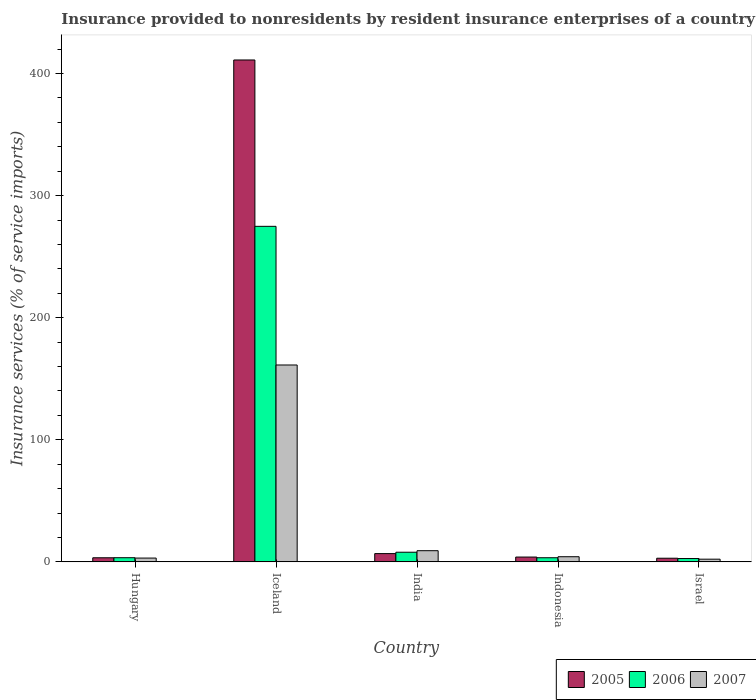How many different coloured bars are there?
Make the answer very short. 3. Are the number of bars per tick equal to the number of legend labels?
Your answer should be very brief. Yes. How many bars are there on the 2nd tick from the left?
Keep it short and to the point. 3. How many bars are there on the 4th tick from the right?
Make the answer very short. 3. What is the label of the 5th group of bars from the left?
Keep it short and to the point. Israel. In how many cases, is the number of bars for a given country not equal to the number of legend labels?
Your answer should be very brief. 0. What is the insurance provided to nonresidents in 2006 in Israel?
Offer a terse response. 2.73. Across all countries, what is the maximum insurance provided to nonresidents in 2007?
Ensure brevity in your answer.  161.27. Across all countries, what is the minimum insurance provided to nonresidents in 2005?
Your answer should be compact. 2.98. What is the total insurance provided to nonresidents in 2005 in the graph?
Provide a short and direct response. 428.22. What is the difference between the insurance provided to nonresidents in 2006 in Iceland and that in Indonesia?
Your response must be concise. 271.48. What is the difference between the insurance provided to nonresidents in 2006 in Hungary and the insurance provided to nonresidents in 2007 in India?
Keep it short and to the point. -5.75. What is the average insurance provided to nonresidents in 2005 per country?
Offer a terse response. 85.64. What is the difference between the insurance provided to nonresidents of/in 2007 and insurance provided to nonresidents of/in 2005 in Hungary?
Give a very brief answer. -0.25. In how many countries, is the insurance provided to nonresidents in 2006 greater than 140 %?
Give a very brief answer. 1. What is the ratio of the insurance provided to nonresidents in 2006 in Hungary to that in Iceland?
Your answer should be very brief. 0.01. Is the insurance provided to nonresidents in 2005 in Hungary less than that in Israel?
Make the answer very short. No. What is the difference between the highest and the second highest insurance provided to nonresidents in 2007?
Make the answer very short. 157.05. What is the difference between the highest and the lowest insurance provided to nonresidents in 2006?
Provide a succinct answer. 272.13. In how many countries, is the insurance provided to nonresidents in 2007 greater than the average insurance provided to nonresidents in 2007 taken over all countries?
Ensure brevity in your answer.  1. What does the 2nd bar from the right in Iceland represents?
Keep it short and to the point. 2006. Is it the case that in every country, the sum of the insurance provided to nonresidents in 2007 and insurance provided to nonresidents in 2005 is greater than the insurance provided to nonresidents in 2006?
Offer a very short reply. Yes. Are all the bars in the graph horizontal?
Ensure brevity in your answer.  No. Does the graph contain grids?
Give a very brief answer. No. Where does the legend appear in the graph?
Provide a succinct answer. Bottom right. What is the title of the graph?
Make the answer very short. Insurance provided to nonresidents by resident insurance enterprises of a country. What is the label or title of the Y-axis?
Keep it short and to the point. Insurance services (% of service imports). What is the Insurance services (% of service imports) in 2005 in Hungary?
Offer a very short reply. 3.36. What is the Insurance services (% of service imports) in 2006 in Hungary?
Your response must be concise. 3.4. What is the Insurance services (% of service imports) of 2007 in Hungary?
Keep it short and to the point. 3.11. What is the Insurance services (% of service imports) in 2005 in Iceland?
Ensure brevity in your answer.  411.14. What is the Insurance services (% of service imports) in 2006 in Iceland?
Provide a succinct answer. 274.86. What is the Insurance services (% of service imports) of 2007 in Iceland?
Provide a succinct answer. 161.27. What is the Insurance services (% of service imports) in 2005 in India?
Your answer should be compact. 6.78. What is the Insurance services (% of service imports) in 2006 in India?
Make the answer very short. 7.9. What is the Insurance services (% of service imports) in 2007 in India?
Your response must be concise. 9.16. What is the Insurance services (% of service imports) of 2005 in Indonesia?
Provide a short and direct response. 3.95. What is the Insurance services (% of service imports) of 2006 in Indonesia?
Provide a succinct answer. 3.38. What is the Insurance services (% of service imports) in 2007 in Indonesia?
Make the answer very short. 4.22. What is the Insurance services (% of service imports) of 2005 in Israel?
Make the answer very short. 2.98. What is the Insurance services (% of service imports) in 2006 in Israel?
Provide a succinct answer. 2.73. What is the Insurance services (% of service imports) of 2007 in Israel?
Keep it short and to the point. 2.21. Across all countries, what is the maximum Insurance services (% of service imports) in 2005?
Offer a terse response. 411.14. Across all countries, what is the maximum Insurance services (% of service imports) of 2006?
Ensure brevity in your answer.  274.86. Across all countries, what is the maximum Insurance services (% of service imports) of 2007?
Make the answer very short. 161.27. Across all countries, what is the minimum Insurance services (% of service imports) in 2005?
Provide a short and direct response. 2.98. Across all countries, what is the minimum Insurance services (% of service imports) of 2006?
Your answer should be compact. 2.73. Across all countries, what is the minimum Insurance services (% of service imports) of 2007?
Provide a succinct answer. 2.21. What is the total Insurance services (% of service imports) in 2005 in the graph?
Keep it short and to the point. 428.22. What is the total Insurance services (% of service imports) in 2006 in the graph?
Offer a terse response. 292.28. What is the total Insurance services (% of service imports) in 2007 in the graph?
Make the answer very short. 179.97. What is the difference between the Insurance services (% of service imports) of 2005 in Hungary and that in Iceland?
Make the answer very short. -407.77. What is the difference between the Insurance services (% of service imports) of 2006 in Hungary and that in Iceland?
Your answer should be very brief. -271.46. What is the difference between the Insurance services (% of service imports) of 2007 in Hungary and that in Iceland?
Make the answer very short. -158.16. What is the difference between the Insurance services (% of service imports) of 2005 in Hungary and that in India?
Provide a short and direct response. -3.42. What is the difference between the Insurance services (% of service imports) of 2006 in Hungary and that in India?
Provide a short and direct response. -4.49. What is the difference between the Insurance services (% of service imports) in 2007 in Hungary and that in India?
Your answer should be compact. -6.05. What is the difference between the Insurance services (% of service imports) in 2005 in Hungary and that in Indonesia?
Keep it short and to the point. -0.59. What is the difference between the Insurance services (% of service imports) in 2006 in Hungary and that in Indonesia?
Offer a very short reply. 0.02. What is the difference between the Insurance services (% of service imports) in 2007 in Hungary and that in Indonesia?
Your response must be concise. -1.11. What is the difference between the Insurance services (% of service imports) in 2005 in Hungary and that in Israel?
Your answer should be compact. 0.38. What is the difference between the Insurance services (% of service imports) in 2006 in Hungary and that in Israel?
Your answer should be very brief. 0.68. What is the difference between the Insurance services (% of service imports) of 2007 in Hungary and that in Israel?
Your response must be concise. 0.91. What is the difference between the Insurance services (% of service imports) of 2005 in Iceland and that in India?
Your answer should be compact. 404.35. What is the difference between the Insurance services (% of service imports) of 2006 in Iceland and that in India?
Your answer should be compact. 266.96. What is the difference between the Insurance services (% of service imports) of 2007 in Iceland and that in India?
Your answer should be very brief. 152.12. What is the difference between the Insurance services (% of service imports) of 2005 in Iceland and that in Indonesia?
Keep it short and to the point. 407.18. What is the difference between the Insurance services (% of service imports) of 2006 in Iceland and that in Indonesia?
Offer a very short reply. 271.48. What is the difference between the Insurance services (% of service imports) in 2007 in Iceland and that in Indonesia?
Provide a short and direct response. 157.05. What is the difference between the Insurance services (% of service imports) of 2005 in Iceland and that in Israel?
Provide a short and direct response. 408.15. What is the difference between the Insurance services (% of service imports) of 2006 in Iceland and that in Israel?
Give a very brief answer. 272.13. What is the difference between the Insurance services (% of service imports) of 2007 in Iceland and that in Israel?
Offer a terse response. 159.07. What is the difference between the Insurance services (% of service imports) of 2005 in India and that in Indonesia?
Your answer should be very brief. 2.83. What is the difference between the Insurance services (% of service imports) of 2006 in India and that in Indonesia?
Your answer should be very brief. 4.52. What is the difference between the Insurance services (% of service imports) of 2007 in India and that in Indonesia?
Offer a terse response. 4.94. What is the difference between the Insurance services (% of service imports) of 2005 in India and that in Israel?
Your response must be concise. 3.8. What is the difference between the Insurance services (% of service imports) of 2006 in India and that in Israel?
Offer a terse response. 5.17. What is the difference between the Insurance services (% of service imports) of 2007 in India and that in Israel?
Provide a short and direct response. 6.95. What is the difference between the Insurance services (% of service imports) in 2005 in Indonesia and that in Israel?
Make the answer very short. 0.97. What is the difference between the Insurance services (% of service imports) of 2006 in Indonesia and that in Israel?
Your response must be concise. 0.65. What is the difference between the Insurance services (% of service imports) in 2007 in Indonesia and that in Israel?
Your answer should be compact. 2.01. What is the difference between the Insurance services (% of service imports) in 2005 in Hungary and the Insurance services (% of service imports) in 2006 in Iceland?
Your response must be concise. -271.5. What is the difference between the Insurance services (% of service imports) of 2005 in Hungary and the Insurance services (% of service imports) of 2007 in Iceland?
Your answer should be very brief. -157.91. What is the difference between the Insurance services (% of service imports) of 2006 in Hungary and the Insurance services (% of service imports) of 2007 in Iceland?
Your response must be concise. -157.87. What is the difference between the Insurance services (% of service imports) in 2005 in Hungary and the Insurance services (% of service imports) in 2006 in India?
Make the answer very short. -4.54. What is the difference between the Insurance services (% of service imports) in 2005 in Hungary and the Insurance services (% of service imports) in 2007 in India?
Offer a terse response. -5.8. What is the difference between the Insurance services (% of service imports) in 2006 in Hungary and the Insurance services (% of service imports) in 2007 in India?
Provide a succinct answer. -5.75. What is the difference between the Insurance services (% of service imports) in 2005 in Hungary and the Insurance services (% of service imports) in 2006 in Indonesia?
Your answer should be very brief. -0.02. What is the difference between the Insurance services (% of service imports) in 2005 in Hungary and the Insurance services (% of service imports) in 2007 in Indonesia?
Keep it short and to the point. -0.86. What is the difference between the Insurance services (% of service imports) of 2006 in Hungary and the Insurance services (% of service imports) of 2007 in Indonesia?
Give a very brief answer. -0.81. What is the difference between the Insurance services (% of service imports) of 2005 in Hungary and the Insurance services (% of service imports) of 2006 in Israel?
Ensure brevity in your answer.  0.63. What is the difference between the Insurance services (% of service imports) of 2005 in Hungary and the Insurance services (% of service imports) of 2007 in Israel?
Provide a succinct answer. 1.16. What is the difference between the Insurance services (% of service imports) of 2006 in Hungary and the Insurance services (% of service imports) of 2007 in Israel?
Your response must be concise. 1.2. What is the difference between the Insurance services (% of service imports) in 2005 in Iceland and the Insurance services (% of service imports) in 2006 in India?
Make the answer very short. 403.24. What is the difference between the Insurance services (% of service imports) of 2005 in Iceland and the Insurance services (% of service imports) of 2007 in India?
Your answer should be compact. 401.98. What is the difference between the Insurance services (% of service imports) in 2006 in Iceland and the Insurance services (% of service imports) in 2007 in India?
Make the answer very short. 265.7. What is the difference between the Insurance services (% of service imports) in 2005 in Iceland and the Insurance services (% of service imports) in 2006 in Indonesia?
Offer a terse response. 407.75. What is the difference between the Insurance services (% of service imports) in 2005 in Iceland and the Insurance services (% of service imports) in 2007 in Indonesia?
Keep it short and to the point. 406.92. What is the difference between the Insurance services (% of service imports) of 2006 in Iceland and the Insurance services (% of service imports) of 2007 in Indonesia?
Your answer should be compact. 270.64. What is the difference between the Insurance services (% of service imports) in 2005 in Iceland and the Insurance services (% of service imports) in 2006 in Israel?
Provide a succinct answer. 408.41. What is the difference between the Insurance services (% of service imports) in 2005 in Iceland and the Insurance services (% of service imports) in 2007 in Israel?
Offer a very short reply. 408.93. What is the difference between the Insurance services (% of service imports) of 2006 in Iceland and the Insurance services (% of service imports) of 2007 in Israel?
Your answer should be compact. 272.66. What is the difference between the Insurance services (% of service imports) in 2005 in India and the Insurance services (% of service imports) in 2006 in Indonesia?
Offer a very short reply. 3.4. What is the difference between the Insurance services (% of service imports) of 2005 in India and the Insurance services (% of service imports) of 2007 in Indonesia?
Your answer should be very brief. 2.56. What is the difference between the Insurance services (% of service imports) in 2006 in India and the Insurance services (% of service imports) in 2007 in Indonesia?
Keep it short and to the point. 3.68. What is the difference between the Insurance services (% of service imports) in 2005 in India and the Insurance services (% of service imports) in 2006 in Israel?
Offer a terse response. 4.05. What is the difference between the Insurance services (% of service imports) of 2005 in India and the Insurance services (% of service imports) of 2007 in Israel?
Your response must be concise. 4.58. What is the difference between the Insurance services (% of service imports) in 2006 in India and the Insurance services (% of service imports) in 2007 in Israel?
Your answer should be compact. 5.69. What is the difference between the Insurance services (% of service imports) in 2005 in Indonesia and the Insurance services (% of service imports) in 2006 in Israel?
Your answer should be compact. 1.22. What is the difference between the Insurance services (% of service imports) of 2005 in Indonesia and the Insurance services (% of service imports) of 2007 in Israel?
Keep it short and to the point. 1.75. What is the difference between the Insurance services (% of service imports) of 2006 in Indonesia and the Insurance services (% of service imports) of 2007 in Israel?
Your answer should be compact. 1.18. What is the average Insurance services (% of service imports) of 2005 per country?
Your answer should be very brief. 85.64. What is the average Insurance services (% of service imports) of 2006 per country?
Give a very brief answer. 58.46. What is the average Insurance services (% of service imports) in 2007 per country?
Make the answer very short. 35.99. What is the difference between the Insurance services (% of service imports) in 2005 and Insurance services (% of service imports) in 2006 in Hungary?
Your answer should be very brief. -0.04. What is the difference between the Insurance services (% of service imports) of 2005 and Insurance services (% of service imports) of 2007 in Hungary?
Offer a very short reply. 0.25. What is the difference between the Insurance services (% of service imports) in 2006 and Insurance services (% of service imports) in 2007 in Hungary?
Offer a very short reply. 0.29. What is the difference between the Insurance services (% of service imports) of 2005 and Insurance services (% of service imports) of 2006 in Iceland?
Keep it short and to the point. 136.27. What is the difference between the Insurance services (% of service imports) in 2005 and Insurance services (% of service imports) in 2007 in Iceland?
Offer a terse response. 249.86. What is the difference between the Insurance services (% of service imports) of 2006 and Insurance services (% of service imports) of 2007 in Iceland?
Provide a succinct answer. 113.59. What is the difference between the Insurance services (% of service imports) of 2005 and Insurance services (% of service imports) of 2006 in India?
Keep it short and to the point. -1.11. What is the difference between the Insurance services (% of service imports) in 2005 and Insurance services (% of service imports) in 2007 in India?
Provide a succinct answer. -2.37. What is the difference between the Insurance services (% of service imports) of 2006 and Insurance services (% of service imports) of 2007 in India?
Keep it short and to the point. -1.26. What is the difference between the Insurance services (% of service imports) of 2005 and Insurance services (% of service imports) of 2006 in Indonesia?
Ensure brevity in your answer.  0.57. What is the difference between the Insurance services (% of service imports) of 2005 and Insurance services (% of service imports) of 2007 in Indonesia?
Keep it short and to the point. -0.27. What is the difference between the Insurance services (% of service imports) of 2006 and Insurance services (% of service imports) of 2007 in Indonesia?
Offer a terse response. -0.84. What is the difference between the Insurance services (% of service imports) in 2005 and Insurance services (% of service imports) in 2006 in Israel?
Offer a very short reply. 0.25. What is the difference between the Insurance services (% of service imports) of 2005 and Insurance services (% of service imports) of 2007 in Israel?
Ensure brevity in your answer.  0.78. What is the difference between the Insurance services (% of service imports) of 2006 and Insurance services (% of service imports) of 2007 in Israel?
Your answer should be very brief. 0.52. What is the ratio of the Insurance services (% of service imports) in 2005 in Hungary to that in Iceland?
Give a very brief answer. 0.01. What is the ratio of the Insurance services (% of service imports) in 2006 in Hungary to that in Iceland?
Provide a short and direct response. 0.01. What is the ratio of the Insurance services (% of service imports) of 2007 in Hungary to that in Iceland?
Provide a short and direct response. 0.02. What is the ratio of the Insurance services (% of service imports) of 2005 in Hungary to that in India?
Keep it short and to the point. 0.5. What is the ratio of the Insurance services (% of service imports) in 2006 in Hungary to that in India?
Your response must be concise. 0.43. What is the ratio of the Insurance services (% of service imports) in 2007 in Hungary to that in India?
Provide a succinct answer. 0.34. What is the ratio of the Insurance services (% of service imports) in 2005 in Hungary to that in Indonesia?
Provide a succinct answer. 0.85. What is the ratio of the Insurance services (% of service imports) in 2007 in Hungary to that in Indonesia?
Make the answer very short. 0.74. What is the ratio of the Insurance services (% of service imports) in 2005 in Hungary to that in Israel?
Your answer should be very brief. 1.13. What is the ratio of the Insurance services (% of service imports) of 2006 in Hungary to that in Israel?
Provide a short and direct response. 1.25. What is the ratio of the Insurance services (% of service imports) in 2007 in Hungary to that in Israel?
Give a very brief answer. 1.41. What is the ratio of the Insurance services (% of service imports) of 2005 in Iceland to that in India?
Offer a terse response. 60.62. What is the ratio of the Insurance services (% of service imports) in 2006 in Iceland to that in India?
Your answer should be very brief. 34.8. What is the ratio of the Insurance services (% of service imports) in 2007 in Iceland to that in India?
Give a very brief answer. 17.61. What is the ratio of the Insurance services (% of service imports) of 2005 in Iceland to that in Indonesia?
Your answer should be compact. 104.01. What is the ratio of the Insurance services (% of service imports) in 2006 in Iceland to that in Indonesia?
Offer a terse response. 81.27. What is the ratio of the Insurance services (% of service imports) of 2007 in Iceland to that in Indonesia?
Offer a very short reply. 38.23. What is the ratio of the Insurance services (% of service imports) in 2005 in Iceland to that in Israel?
Your response must be concise. 137.84. What is the ratio of the Insurance services (% of service imports) of 2006 in Iceland to that in Israel?
Offer a very short reply. 100.7. What is the ratio of the Insurance services (% of service imports) of 2007 in Iceland to that in Israel?
Make the answer very short. 73.09. What is the ratio of the Insurance services (% of service imports) in 2005 in India to that in Indonesia?
Give a very brief answer. 1.72. What is the ratio of the Insurance services (% of service imports) in 2006 in India to that in Indonesia?
Make the answer very short. 2.33. What is the ratio of the Insurance services (% of service imports) in 2007 in India to that in Indonesia?
Your answer should be compact. 2.17. What is the ratio of the Insurance services (% of service imports) of 2005 in India to that in Israel?
Your answer should be very brief. 2.27. What is the ratio of the Insurance services (% of service imports) in 2006 in India to that in Israel?
Your answer should be very brief. 2.89. What is the ratio of the Insurance services (% of service imports) of 2007 in India to that in Israel?
Your response must be concise. 4.15. What is the ratio of the Insurance services (% of service imports) of 2005 in Indonesia to that in Israel?
Provide a short and direct response. 1.33. What is the ratio of the Insurance services (% of service imports) in 2006 in Indonesia to that in Israel?
Give a very brief answer. 1.24. What is the ratio of the Insurance services (% of service imports) in 2007 in Indonesia to that in Israel?
Your response must be concise. 1.91. What is the difference between the highest and the second highest Insurance services (% of service imports) in 2005?
Make the answer very short. 404.35. What is the difference between the highest and the second highest Insurance services (% of service imports) of 2006?
Keep it short and to the point. 266.96. What is the difference between the highest and the second highest Insurance services (% of service imports) of 2007?
Ensure brevity in your answer.  152.12. What is the difference between the highest and the lowest Insurance services (% of service imports) in 2005?
Your answer should be very brief. 408.15. What is the difference between the highest and the lowest Insurance services (% of service imports) in 2006?
Keep it short and to the point. 272.13. What is the difference between the highest and the lowest Insurance services (% of service imports) in 2007?
Ensure brevity in your answer.  159.07. 